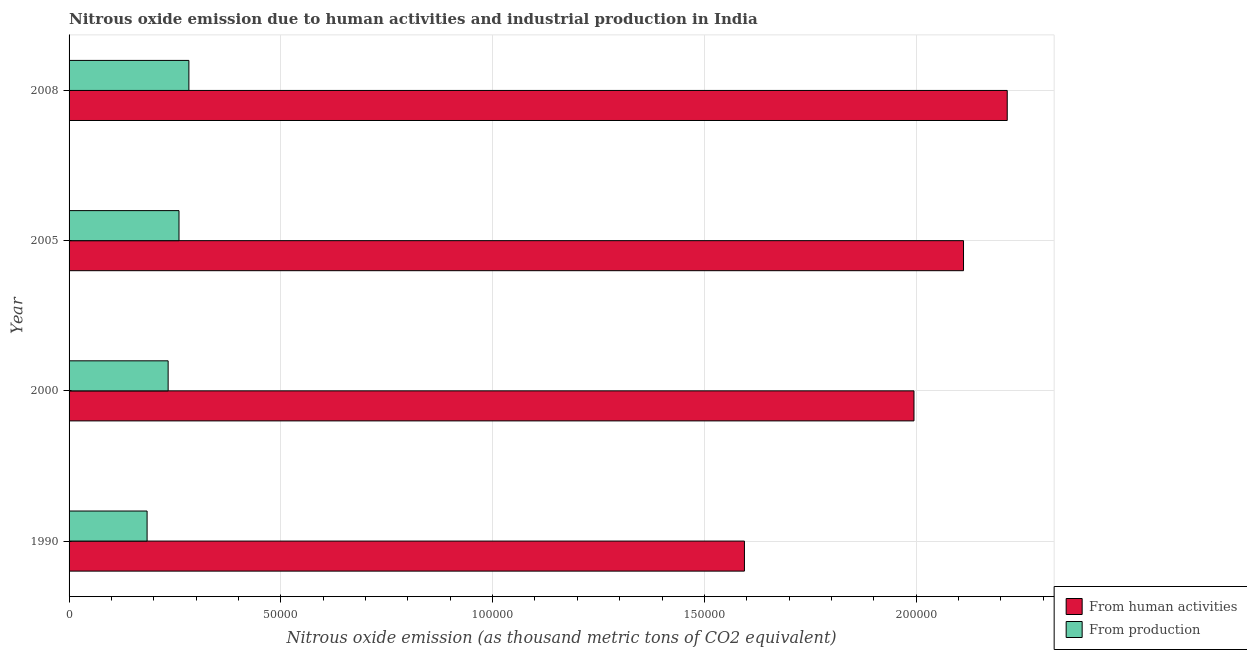How many groups of bars are there?
Make the answer very short. 4. Are the number of bars per tick equal to the number of legend labels?
Your response must be concise. Yes. How many bars are there on the 1st tick from the top?
Provide a succinct answer. 2. What is the label of the 4th group of bars from the top?
Provide a short and direct response. 1990. In how many cases, is the number of bars for a given year not equal to the number of legend labels?
Offer a very short reply. 0. What is the amount of emissions from human activities in 1990?
Your answer should be very brief. 1.59e+05. Across all years, what is the maximum amount of emissions generated from industries?
Offer a very short reply. 2.83e+04. Across all years, what is the minimum amount of emissions generated from industries?
Provide a succinct answer. 1.84e+04. What is the total amount of emissions from human activities in the graph?
Offer a very short reply. 7.92e+05. What is the difference between the amount of emissions from human activities in 1990 and that in 2008?
Keep it short and to the point. -6.21e+04. What is the difference between the amount of emissions generated from industries in 2000 and the amount of emissions from human activities in 2005?
Offer a terse response. -1.88e+05. What is the average amount of emissions generated from industries per year?
Provide a succinct answer. 2.40e+04. In the year 2005, what is the difference between the amount of emissions generated from industries and amount of emissions from human activities?
Provide a short and direct response. -1.85e+05. In how many years, is the amount of emissions from human activities greater than 220000 thousand metric tons?
Provide a short and direct response. 1. What is the ratio of the amount of emissions generated from industries in 1990 to that in 2000?
Provide a short and direct response. 0.79. Is the amount of emissions from human activities in 2005 less than that in 2008?
Give a very brief answer. Yes. Is the difference between the amount of emissions from human activities in 1990 and 2008 greater than the difference between the amount of emissions generated from industries in 1990 and 2008?
Your answer should be compact. No. What is the difference between the highest and the second highest amount of emissions generated from industries?
Provide a succinct answer. 2335.9. What is the difference between the highest and the lowest amount of emissions from human activities?
Offer a very short reply. 6.21e+04. In how many years, is the amount of emissions generated from industries greater than the average amount of emissions generated from industries taken over all years?
Your answer should be very brief. 2. Is the sum of the amount of emissions generated from industries in 1990 and 2005 greater than the maximum amount of emissions from human activities across all years?
Make the answer very short. No. What does the 1st bar from the top in 2005 represents?
Your answer should be compact. From production. What does the 1st bar from the bottom in 2005 represents?
Provide a succinct answer. From human activities. How many bars are there?
Give a very brief answer. 8. Are the values on the major ticks of X-axis written in scientific E-notation?
Offer a terse response. No. Does the graph contain grids?
Ensure brevity in your answer.  Yes. How are the legend labels stacked?
Offer a very short reply. Vertical. What is the title of the graph?
Offer a terse response. Nitrous oxide emission due to human activities and industrial production in India. What is the label or title of the X-axis?
Your response must be concise. Nitrous oxide emission (as thousand metric tons of CO2 equivalent). What is the Nitrous oxide emission (as thousand metric tons of CO2 equivalent) of From human activities in 1990?
Keep it short and to the point. 1.59e+05. What is the Nitrous oxide emission (as thousand metric tons of CO2 equivalent) of From production in 1990?
Ensure brevity in your answer.  1.84e+04. What is the Nitrous oxide emission (as thousand metric tons of CO2 equivalent) of From human activities in 2000?
Your answer should be compact. 1.99e+05. What is the Nitrous oxide emission (as thousand metric tons of CO2 equivalent) of From production in 2000?
Make the answer very short. 2.34e+04. What is the Nitrous oxide emission (as thousand metric tons of CO2 equivalent) of From human activities in 2005?
Your response must be concise. 2.11e+05. What is the Nitrous oxide emission (as thousand metric tons of CO2 equivalent) in From production in 2005?
Your answer should be very brief. 2.60e+04. What is the Nitrous oxide emission (as thousand metric tons of CO2 equivalent) in From human activities in 2008?
Your response must be concise. 2.22e+05. What is the Nitrous oxide emission (as thousand metric tons of CO2 equivalent) of From production in 2008?
Offer a terse response. 2.83e+04. Across all years, what is the maximum Nitrous oxide emission (as thousand metric tons of CO2 equivalent) of From human activities?
Your answer should be compact. 2.22e+05. Across all years, what is the maximum Nitrous oxide emission (as thousand metric tons of CO2 equivalent) of From production?
Provide a short and direct response. 2.83e+04. Across all years, what is the minimum Nitrous oxide emission (as thousand metric tons of CO2 equivalent) of From human activities?
Provide a short and direct response. 1.59e+05. Across all years, what is the minimum Nitrous oxide emission (as thousand metric tons of CO2 equivalent) of From production?
Your answer should be compact. 1.84e+04. What is the total Nitrous oxide emission (as thousand metric tons of CO2 equivalent) in From human activities in the graph?
Keep it short and to the point. 7.92e+05. What is the total Nitrous oxide emission (as thousand metric tons of CO2 equivalent) of From production in the graph?
Make the answer very short. 9.61e+04. What is the difference between the Nitrous oxide emission (as thousand metric tons of CO2 equivalent) of From human activities in 1990 and that in 2000?
Make the answer very short. -4.00e+04. What is the difference between the Nitrous oxide emission (as thousand metric tons of CO2 equivalent) of From production in 1990 and that in 2000?
Your answer should be very brief. -4968.5. What is the difference between the Nitrous oxide emission (as thousand metric tons of CO2 equivalent) of From human activities in 1990 and that in 2005?
Offer a terse response. -5.17e+04. What is the difference between the Nitrous oxide emission (as thousand metric tons of CO2 equivalent) of From production in 1990 and that in 2005?
Offer a very short reply. -7531.6. What is the difference between the Nitrous oxide emission (as thousand metric tons of CO2 equivalent) in From human activities in 1990 and that in 2008?
Make the answer very short. -6.21e+04. What is the difference between the Nitrous oxide emission (as thousand metric tons of CO2 equivalent) in From production in 1990 and that in 2008?
Make the answer very short. -9867.5. What is the difference between the Nitrous oxide emission (as thousand metric tons of CO2 equivalent) of From human activities in 2000 and that in 2005?
Make the answer very short. -1.17e+04. What is the difference between the Nitrous oxide emission (as thousand metric tons of CO2 equivalent) in From production in 2000 and that in 2005?
Keep it short and to the point. -2563.1. What is the difference between the Nitrous oxide emission (as thousand metric tons of CO2 equivalent) of From human activities in 2000 and that in 2008?
Offer a very short reply. -2.20e+04. What is the difference between the Nitrous oxide emission (as thousand metric tons of CO2 equivalent) in From production in 2000 and that in 2008?
Offer a very short reply. -4899. What is the difference between the Nitrous oxide emission (as thousand metric tons of CO2 equivalent) of From human activities in 2005 and that in 2008?
Provide a succinct answer. -1.03e+04. What is the difference between the Nitrous oxide emission (as thousand metric tons of CO2 equivalent) in From production in 2005 and that in 2008?
Ensure brevity in your answer.  -2335.9. What is the difference between the Nitrous oxide emission (as thousand metric tons of CO2 equivalent) of From human activities in 1990 and the Nitrous oxide emission (as thousand metric tons of CO2 equivalent) of From production in 2000?
Your answer should be very brief. 1.36e+05. What is the difference between the Nitrous oxide emission (as thousand metric tons of CO2 equivalent) of From human activities in 1990 and the Nitrous oxide emission (as thousand metric tons of CO2 equivalent) of From production in 2005?
Provide a short and direct response. 1.34e+05. What is the difference between the Nitrous oxide emission (as thousand metric tons of CO2 equivalent) in From human activities in 1990 and the Nitrous oxide emission (as thousand metric tons of CO2 equivalent) in From production in 2008?
Your answer should be compact. 1.31e+05. What is the difference between the Nitrous oxide emission (as thousand metric tons of CO2 equivalent) in From human activities in 2000 and the Nitrous oxide emission (as thousand metric tons of CO2 equivalent) in From production in 2005?
Provide a short and direct response. 1.74e+05. What is the difference between the Nitrous oxide emission (as thousand metric tons of CO2 equivalent) of From human activities in 2000 and the Nitrous oxide emission (as thousand metric tons of CO2 equivalent) of From production in 2008?
Your response must be concise. 1.71e+05. What is the difference between the Nitrous oxide emission (as thousand metric tons of CO2 equivalent) in From human activities in 2005 and the Nitrous oxide emission (as thousand metric tons of CO2 equivalent) in From production in 2008?
Your answer should be compact. 1.83e+05. What is the average Nitrous oxide emission (as thousand metric tons of CO2 equivalent) in From human activities per year?
Provide a succinct answer. 1.98e+05. What is the average Nitrous oxide emission (as thousand metric tons of CO2 equivalent) of From production per year?
Your answer should be very brief. 2.40e+04. In the year 1990, what is the difference between the Nitrous oxide emission (as thousand metric tons of CO2 equivalent) of From human activities and Nitrous oxide emission (as thousand metric tons of CO2 equivalent) of From production?
Offer a very short reply. 1.41e+05. In the year 2000, what is the difference between the Nitrous oxide emission (as thousand metric tons of CO2 equivalent) of From human activities and Nitrous oxide emission (as thousand metric tons of CO2 equivalent) of From production?
Ensure brevity in your answer.  1.76e+05. In the year 2005, what is the difference between the Nitrous oxide emission (as thousand metric tons of CO2 equivalent) in From human activities and Nitrous oxide emission (as thousand metric tons of CO2 equivalent) in From production?
Ensure brevity in your answer.  1.85e+05. In the year 2008, what is the difference between the Nitrous oxide emission (as thousand metric tons of CO2 equivalent) of From human activities and Nitrous oxide emission (as thousand metric tons of CO2 equivalent) of From production?
Keep it short and to the point. 1.93e+05. What is the ratio of the Nitrous oxide emission (as thousand metric tons of CO2 equivalent) in From human activities in 1990 to that in 2000?
Ensure brevity in your answer.  0.8. What is the ratio of the Nitrous oxide emission (as thousand metric tons of CO2 equivalent) of From production in 1990 to that in 2000?
Ensure brevity in your answer.  0.79. What is the ratio of the Nitrous oxide emission (as thousand metric tons of CO2 equivalent) of From human activities in 1990 to that in 2005?
Make the answer very short. 0.76. What is the ratio of the Nitrous oxide emission (as thousand metric tons of CO2 equivalent) of From production in 1990 to that in 2005?
Your answer should be very brief. 0.71. What is the ratio of the Nitrous oxide emission (as thousand metric tons of CO2 equivalent) in From human activities in 1990 to that in 2008?
Keep it short and to the point. 0.72. What is the ratio of the Nitrous oxide emission (as thousand metric tons of CO2 equivalent) of From production in 1990 to that in 2008?
Ensure brevity in your answer.  0.65. What is the ratio of the Nitrous oxide emission (as thousand metric tons of CO2 equivalent) in From human activities in 2000 to that in 2005?
Your answer should be compact. 0.94. What is the ratio of the Nitrous oxide emission (as thousand metric tons of CO2 equivalent) of From production in 2000 to that in 2005?
Offer a very short reply. 0.9. What is the ratio of the Nitrous oxide emission (as thousand metric tons of CO2 equivalent) of From human activities in 2000 to that in 2008?
Offer a very short reply. 0.9. What is the ratio of the Nitrous oxide emission (as thousand metric tons of CO2 equivalent) in From production in 2000 to that in 2008?
Offer a very short reply. 0.83. What is the ratio of the Nitrous oxide emission (as thousand metric tons of CO2 equivalent) in From human activities in 2005 to that in 2008?
Give a very brief answer. 0.95. What is the ratio of the Nitrous oxide emission (as thousand metric tons of CO2 equivalent) in From production in 2005 to that in 2008?
Make the answer very short. 0.92. What is the difference between the highest and the second highest Nitrous oxide emission (as thousand metric tons of CO2 equivalent) of From human activities?
Your answer should be very brief. 1.03e+04. What is the difference between the highest and the second highest Nitrous oxide emission (as thousand metric tons of CO2 equivalent) in From production?
Keep it short and to the point. 2335.9. What is the difference between the highest and the lowest Nitrous oxide emission (as thousand metric tons of CO2 equivalent) in From human activities?
Offer a very short reply. 6.21e+04. What is the difference between the highest and the lowest Nitrous oxide emission (as thousand metric tons of CO2 equivalent) in From production?
Offer a very short reply. 9867.5. 